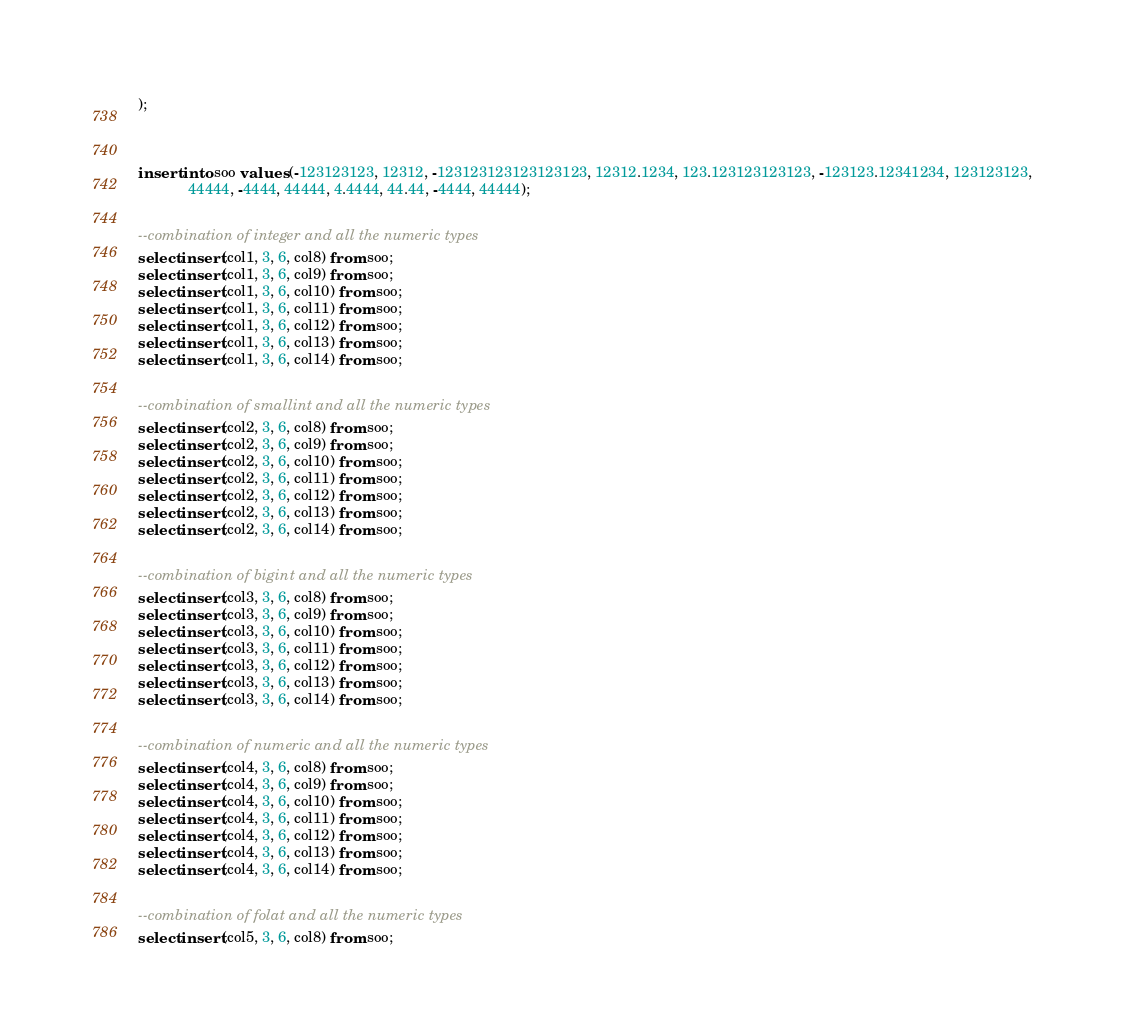Convert code to text. <code><loc_0><loc_0><loc_500><loc_500><_SQL_>);



insert into soo values (-123123123, 12312, -123123123123123123, 12312.1234, 123.123123123123, -123123.12341234, 123123123,
			44444, -4444, 44444, 4.4444, 44.44, -4444, 44444);


--combination of integer and all the numeric types
select insert(col1, 3, 6, col8) from soo;
select insert(col1, 3, 6, col9) from soo;
select insert(col1, 3, 6, col10) from soo;
select insert(col1, 3, 6, col11) from soo;
select insert(col1, 3, 6, col12) from soo;
select insert(col1, 3, 6, col13) from soo;
select insert(col1, 3, 6, col14) from soo;


--combination of smallint and all the numeric types
select insert(col2, 3, 6, col8) from soo;
select insert(col2, 3, 6, col9) from soo;
select insert(col2, 3, 6, col10) from soo;
select insert(col2, 3, 6, col11) from soo;
select insert(col2, 3, 6, col12) from soo;
select insert(col2, 3, 6, col13) from soo;
select insert(col2, 3, 6, col14) from soo;


--combination of bigint and all the numeric types
select insert(col3, 3, 6, col8) from soo;
select insert(col3, 3, 6, col9) from soo;
select insert(col3, 3, 6, col10) from soo;
select insert(col3, 3, 6, col11) from soo;
select insert(col3, 3, 6, col12) from soo;
select insert(col3, 3, 6, col13) from soo;
select insert(col3, 3, 6, col14) from soo;


--combination of numeric and all the numeric types
select insert(col4, 3, 6, col8) from soo;
select insert(col4, 3, 6, col9) from soo;
select insert(col4, 3, 6, col10) from soo;
select insert(col4, 3, 6, col11) from soo;
select insert(col4, 3, 6, col12) from soo;
select insert(col4, 3, 6, col13) from soo;
select insert(col4, 3, 6, col14) from soo;


--combination of folat and all the numeric types
select insert(col5, 3, 6, col8) from soo;</code> 